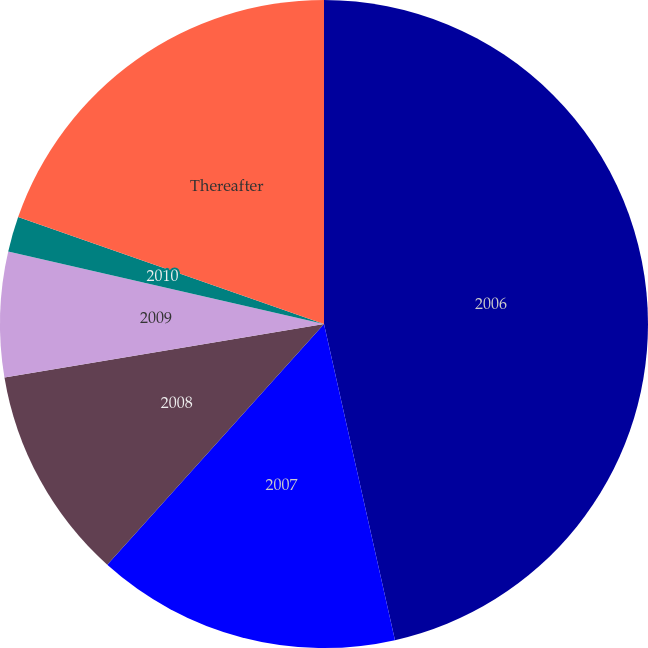Convert chart to OTSL. <chart><loc_0><loc_0><loc_500><loc_500><pie_chart><fcel>2006<fcel>2007<fcel>2008<fcel>2009<fcel>2010<fcel>Thereafter<nl><fcel>46.49%<fcel>15.18%<fcel>10.7%<fcel>6.23%<fcel>1.76%<fcel>19.65%<nl></chart> 